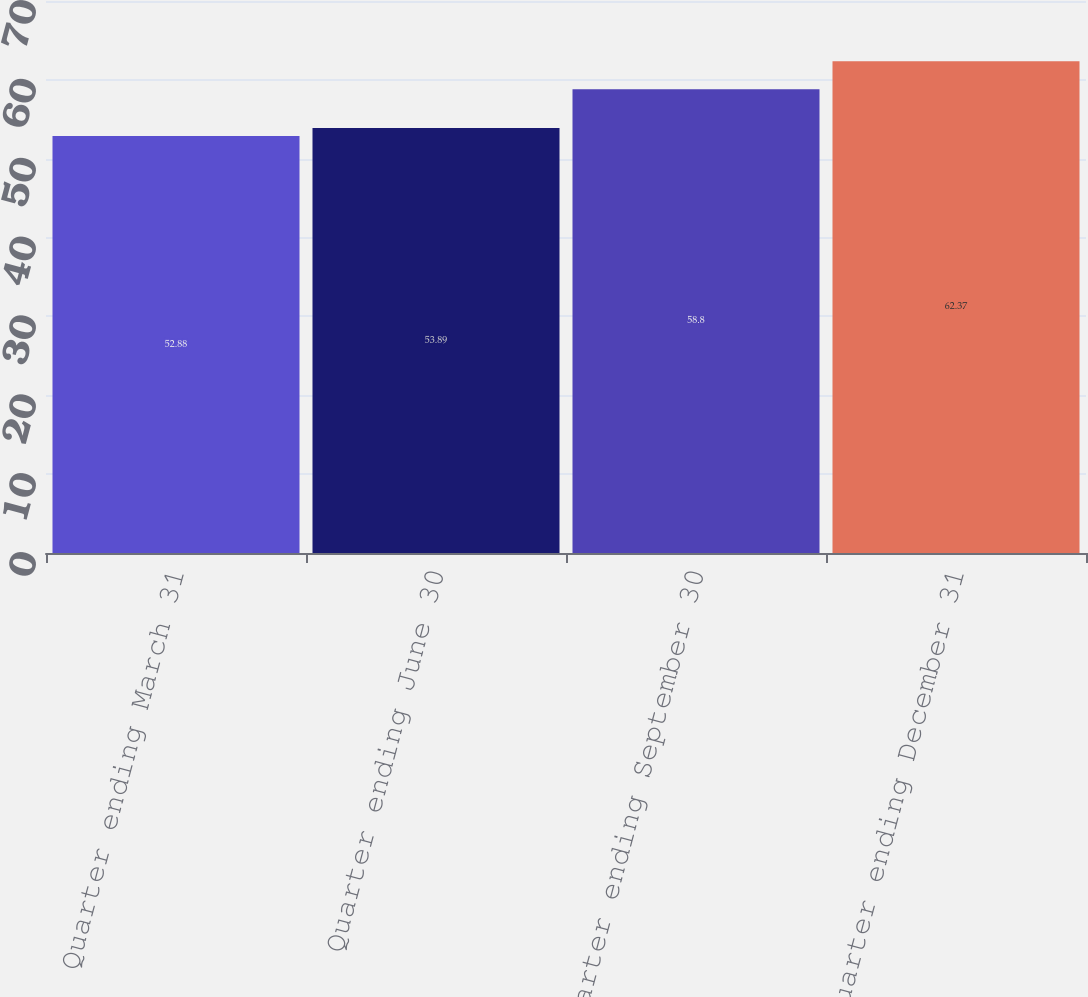<chart> <loc_0><loc_0><loc_500><loc_500><bar_chart><fcel>Quarter ending March 31<fcel>Quarter ending June 30<fcel>Quarter ending September 30<fcel>Quarter ending December 31<nl><fcel>52.88<fcel>53.89<fcel>58.8<fcel>62.37<nl></chart> 